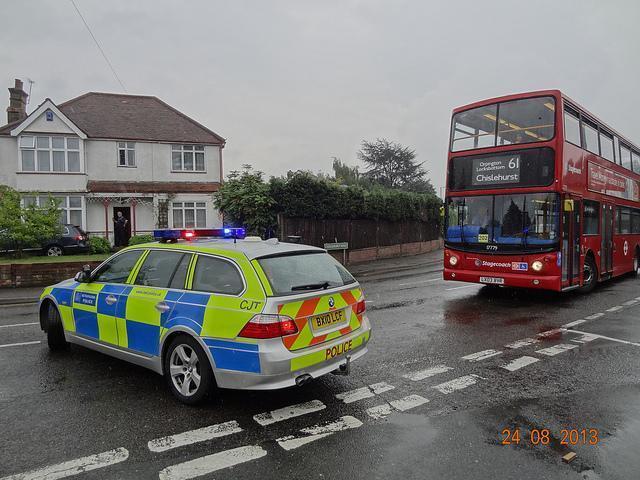How many horses are on the beach?
Give a very brief answer. 0. 